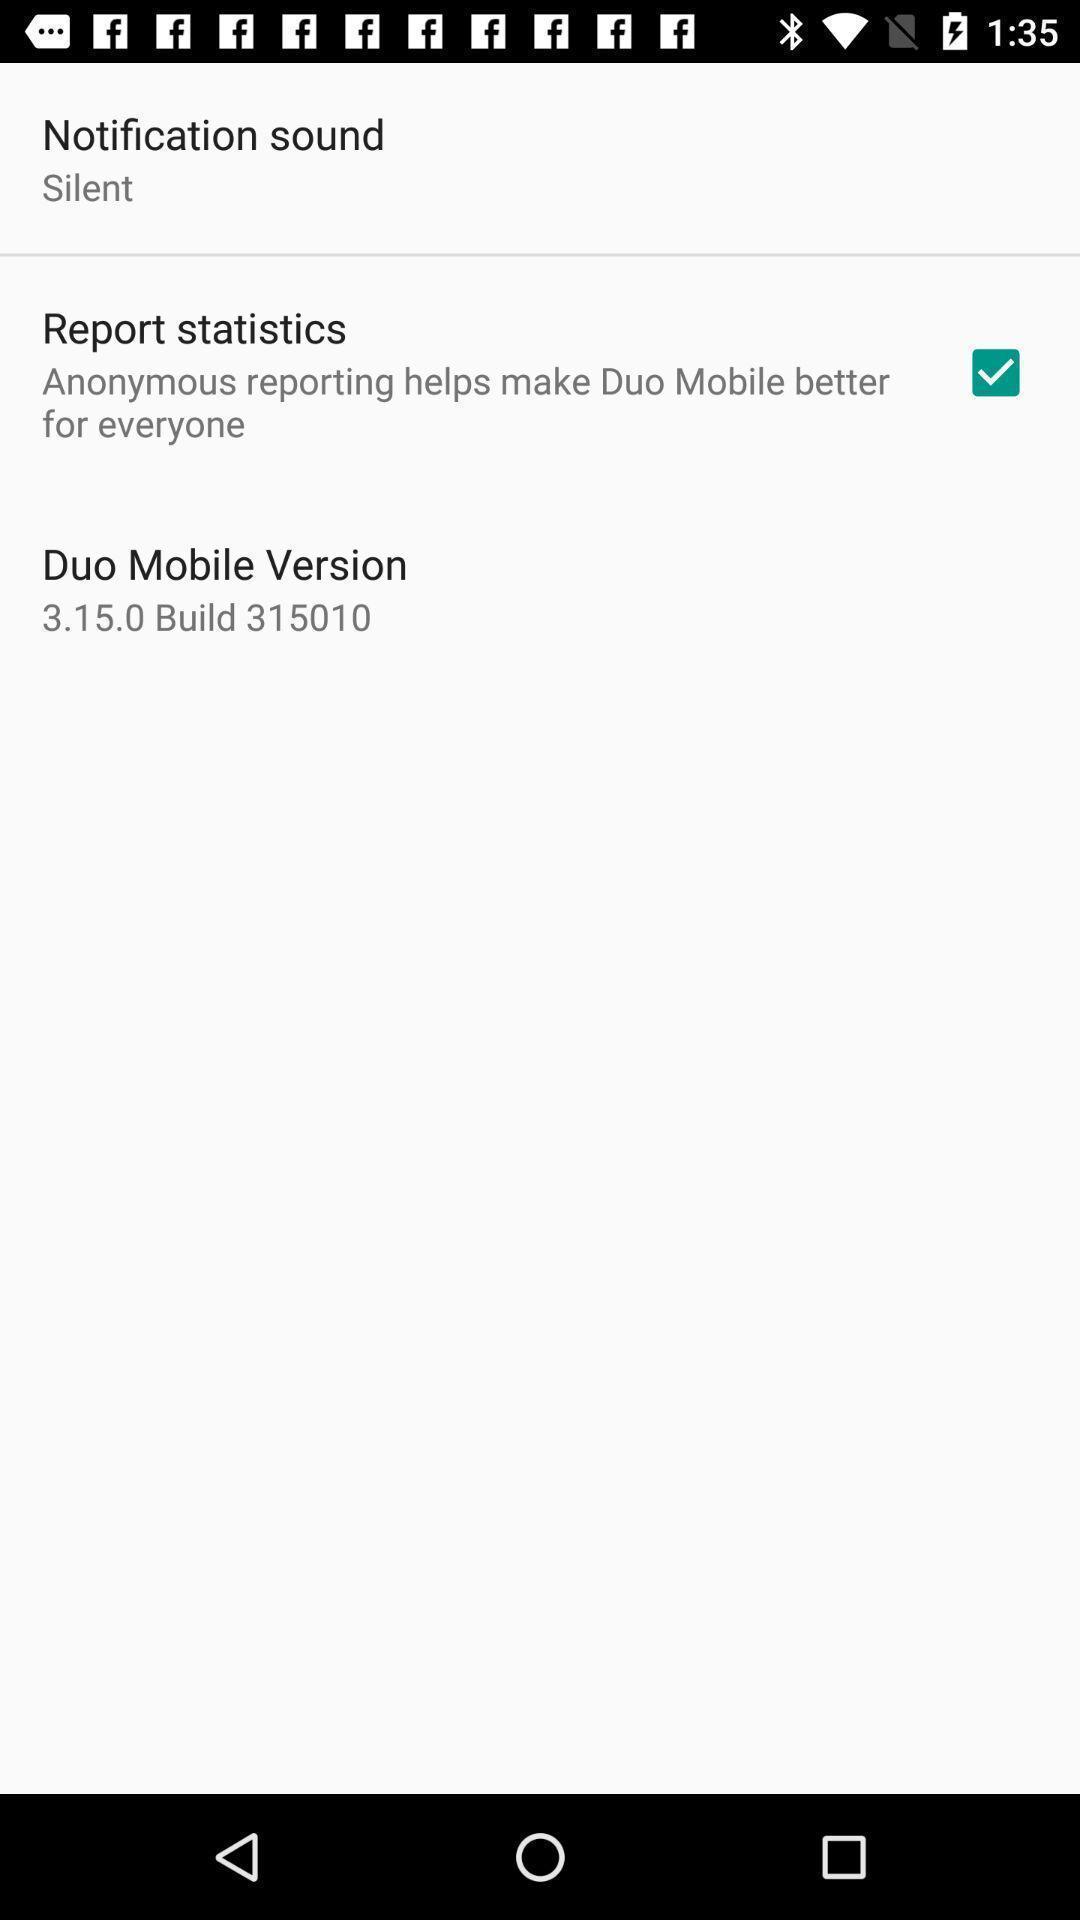Explain what's happening in this screen capture. Screen shows different options. 